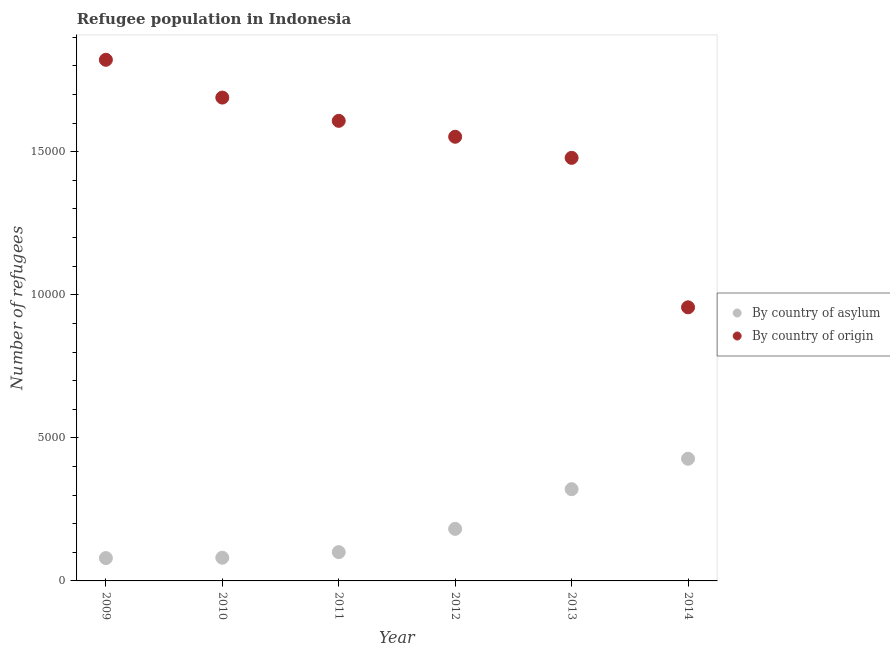How many different coloured dotlines are there?
Offer a terse response. 2. What is the number of refugees by country of origin in 2011?
Provide a short and direct response. 1.61e+04. Across all years, what is the maximum number of refugees by country of asylum?
Ensure brevity in your answer.  4270. Across all years, what is the minimum number of refugees by country of origin?
Make the answer very short. 9562. In which year was the number of refugees by country of origin maximum?
Offer a very short reply. 2009. What is the total number of refugees by country of asylum in the graph?
Provide a short and direct response. 1.19e+04. What is the difference between the number of refugees by country of asylum in 2009 and that in 2014?
Offer a terse response. -3472. What is the difference between the number of refugees by country of asylum in 2010 and the number of refugees by country of origin in 2009?
Ensure brevity in your answer.  -1.74e+04. What is the average number of refugees by country of origin per year?
Ensure brevity in your answer.  1.52e+04. In the year 2012, what is the difference between the number of refugees by country of asylum and number of refugees by country of origin?
Your response must be concise. -1.37e+04. What is the ratio of the number of refugees by country of origin in 2011 to that in 2013?
Provide a succinct answer. 1.09. What is the difference between the highest and the second highest number of refugees by country of asylum?
Offer a very short reply. 1064. What is the difference between the highest and the lowest number of refugees by country of asylum?
Your answer should be compact. 3472. Is the number of refugees by country of asylum strictly less than the number of refugees by country of origin over the years?
Keep it short and to the point. Yes. How many dotlines are there?
Provide a short and direct response. 2. What is the difference between two consecutive major ticks on the Y-axis?
Make the answer very short. 5000. Does the graph contain any zero values?
Provide a succinct answer. No. Does the graph contain grids?
Your answer should be very brief. No. Where does the legend appear in the graph?
Offer a very short reply. Center right. How are the legend labels stacked?
Provide a short and direct response. Vertical. What is the title of the graph?
Your answer should be compact. Refugee population in Indonesia. Does "% of gross capital formation" appear as one of the legend labels in the graph?
Your answer should be very brief. No. What is the label or title of the Y-axis?
Provide a short and direct response. Number of refugees. What is the Number of refugees of By country of asylum in 2009?
Your answer should be very brief. 798. What is the Number of refugees of By country of origin in 2009?
Ensure brevity in your answer.  1.82e+04. What is the Number of refugees in By country of asylum in 2010?
Your response must be concise. 811. What is the Number of refugees in By country of origin in 2010?
Keep it short and to the point. 1.69e+04. What is the Number of refugees in By country of asylum in 2011?
Your answer should be very brief. 1006. What is the Number of refugees of By country of origin in 2011?
Provide a succinct answer. 1.61e+04. What is the Number of refugees in By country of asylum in 2012?
Provide a short and direct response. 1819. What is the Number of refugees in By country of origin in 2012?
Your answer should be very brief. 1.55e+04. What is the Number of refugees in By country of asylum in 2013?
Your answer should be compact. 3206. What is the Number of refugees in By country of origin in 2013?
Provide a succinct answer. 1.48e+04. What is the Number of refugees in By country of asylum in 2014?
Your answer should be compact. 4270. What is the Number of refugees of By country of origin in 2014?
Provide a succinct answer. 9562. Across all years, what is the maximum Number of refugees of By country of asylum?
Offer a very short reply. 4270. Across all years, what is the maximum Number of refugees in By country of origin?
Offer a terse response. 1.82e+04. Across all years, what is the minimum Number of refugees of By country of asylum?
Make the answer very short. 798. Across all years, what is the minimum Number of refugees in By country of origin?
Your answer should be compact. 9562. What is the total Number of refugees of By country of asylum in the graph?
Provide a short and direct response. 1.19e+04. What is the total Number of refugees of By country of origin in the graph?
Provide a short and direct response. 9.11e+04. What is the difference between the Number of refugees of By country of asylum in 2009 and that in 2010?
Provide a short and direct response. -13. What is the difference between the Number of refugees in By country of origin in 2009 and that in 2010?
Your response must be concise. 1321. What is the difference between the Number of refugees of By country of asylum in 2009 and that in 2011?
Keep it short and to the point. -208. What is the difference between the Number of refugees in By country of origin in 2009 and that in 2011?
Offer a very short reply. 2134. What is the difference between the Number of refugees in By country of asylum in 2009 and that in 2012?
Keep it short and to the point. -1021. What is the difference between the Number of refugees of By country of origin in 2009 and that in 2012?
Give a very brief answer. 2690. What is the difference between the Number of refugees of By country of asylum in 2009 and that in 2013?
Provide a succinct answer. -2408. What is the difference between the Number of refugees of By country of origin in 2009 and that in 2013?
Your response must be concise. 3427. What is the difference between the Number of refugees of By country of asylum in 2009 and that in 2014?
Your answer should be compact. -3472. What is the difference between the Number of refugees of By country of origin in 2009 and that in 2014?
Make the answer very short. 8651. What is the difference between the Number of refugees of By country of asylum in 2010 and that in 2011?
Provide a succinct answer. -195. What is the difference between the Number of refugees in By country of origin in 2010 and that in 2011?
Provide a succinct answer. 813. What is the difference between the Number of refugees of By country of asylum in 2010 and that in 2012?
Provide a succinct answer. -1008. What is the difference between the Number of refugees of By country of origin in 2010 and that in 2012?
Provide a succinct answer. 1369. What is the difference between the Number of refugees in By country of asylum in 2010 and that in 2013?
Give a very brief answer. -2395. What is the difference between the Number of refugees in By country of origin in 2010 and that in 2013?
Your response must be concise. 2106. What is the difference between the Number of refugees of By country of asylum in 2010 and that in 2014?
Keep it short and to the point. -3459. What is the difference between the Number of refugees in By country of origin in 2010 and that in 2014?
Ensure brevity in your answer.  7330. What is the difference between the Number of refugees of By country of asylum in 2011 and that in 2012?
Your answer should be very brief. -813. What is the difference between the Number of refugees in By country of origin in 2011 and that in 2012?
Ensure brevity in your answer.  556. What is the difference between the Number of refugees of By country of asylum in 2011 and that in 2013?
Your answer should be very brief. -2200. What is the difference between the Number of refugees of By country of origin in 2011 and that in 2013?
Your answer should be very brief. 1293. What is the difference between the Number of refugees in By country of asylum in 2011 and that in 2014?
Make the answer very short. -3264. What is the difference between the Number of refugees in By country of origin in 2011 and that in 2014?
Offer a very short reply. 6517. What is the difference between the Number of refugees of By country of asylum in 2012 and that in 2013?
Provide a succinct answer. -1387. What is the difference between the Number of refugees of By country of origin in 2012 and that in 2013?
Provide a succinct answer. 737. What is the difference between the Number of refugees of By country of asylum in 2012 and that in 2014?
Give a very brief answer. -2451. What is the difference between the Number of refugees of By country of origin in 2012 and that in 2014?
Keep it short and to the point. 5961. What is the difference between the Number of refugees of By country of asylum in 2013 and that in 2014?
Offer a terse response. -1064. What is the difference between the Number of refugees in By country of origin in 2013 and that in 2014?
Keep it short and to the point. 5224. What is the difference between the Number of refugees in By country of asylum in 2009 and the Number of refugees in By country of origin in 2010?
Offer a terse response. -1.61e+04. What is the difference between the Number of refugees of By country of asylum in 2009 and the Number of refugees of By country of origin in 2011?
Your answer should be very brief. -1.53e+04. What is the difference between the Number of refugees of By country of asylum in 2009 and the Number of refugees of By country of origin in 2012?
Your answer should be very brief. -1.47e+04. What is the difference between the Number of refugees of By country of asylum in 2009 and the Number of refugees of By country of origin in 2013?
Give a very brief answer. -1.40e+04. What is the difference between the Number of refugees in By country of asylum in 2009 and the Number of refugees in By country of origin in 2014?
Provide a succinct answer. -8764. What is the difference between the Number of refugees in By country of asylum in 2010 and the Number of refugees in By country of origin in 2011?
Offer a very short reply. -1.53e+04. What is the difference between the Number of refugees in By country of asylum in 2010 and the Number of refugees in By country of origin in 2012?
Ensure brevity in your answer.  -1.47e+04. What is the difference between the Number of refugees in By country of asylum in 2010 and the Number of refugees in By country of origin in 2013?
Your answer should be compact. -1.40e+04. What is the difference between the Number of refugees of By country of asylum in 2010 and the Number of refugees of By country of origin in 2014?
Provide a succinct answer. -8751. What is the difference between the Number of refugees in By country of asylum in 2011 and the Number of refugees in By country of origin in 2012?
Offer a very short reply. -1.45e+04. What is the difference between the Number of refugees of By country of asylum in 2011 and the Number of refugees of By country of origin in 2013?
Offer a terse response. -1.38e+04. What is the difference between the Number of refugees of By country of asylum in 2011 and the Number of refugees of By country of origin in 2014?
Your answer should be compact. -8556. What is the difference between the Number of refugees of By country of asylum in 2012 and the Number of refugees of By country of origin in 2013?
Offer a terse response. -1.30e+04. What is the difference between the Number of refugees in By country of asylum in 2012 and the Number of refugees in By country of origin in 2014?
Your response must be concise. -7743. What is the difference between the Number of refugees of By country of asylum in 2013 and the Number of refugees of By country of origin in 2014?
Make the answer very short. -6356. What is the average Number of refugees in By country of asylum per year?
Give a very brief answer. 1985. What is the average Number of refugees in By country of origin per year?
Offer a terse response. 1.52e+04. In the year 2009, what is the difference between the Number of refugees in By country of asylum and Number of refugees in By country of origin?
Give a very brief answer. -1.74e+04. In the year 2010, what is the difference between the Number of refugees in By country of asylum and Number of refugees in By country of origin?
Keep it short and to the point. -1.61e+04. In the year 2011, what is the difference between the Number of refugees in By country of asylum and Number of refugees in By country of origin?
Your answer should be very brief. -1.51e+04. In the year 2012, what is the difference between the Number of refugees in By country of asylum and Number of refugees in By country of origin?
Give a very brief answer. -1.37e+04. In the year 2013, what is the difference between the Number of refugees of By country of asylum and Number of refugees of By country of origin?
Ensure brevity in your answer.  -1.16e+04. In the year 2014, what is the difference between the Number of refugees of By country of asylum and Number of refugees of By country of origin?
Ensure brevity in your answer.  -5292. What is the ratio of the Number of refugees of By country of asylum in 2009 to that in 2010?
Offer a very short reply. 0.98. What is the ratio of the Number of refugees of By country of origin in 2009 to that in 2010?
Offer a terse response. 1.08. What is the ratio of the Number of refugees in By country of asylum in 2009 to that in 2011?
Make the answer very short. 0.79. What is the ratio of the Number of refugees of By country of origin in 2009 to that in 2011?
Give a very brief answer. 1.13. What is the ratio of the Number of refugees of By country of asylum in 2009 to that in 2012?
Provide a succinct answer. 0.44. What is the ratio of the Number of refugees in By country of origin in 2009 to that in 2012?
Make the answer very short. 1.17. What is the ratio of the Number of refugees in By country of asylum in 2009 to that in 2013?
Your response must be concise. 0.25. What is the ratio of the Number of refugees in By country of origin in 2009 to that in 2013?
Your response must be concise. 1.23. What is the ratio of the Number of refugees of By country of asylum in 2009 to that in 2014?
Provide a short and direct response. 0.19. What is the ratio of the Number of refugees in By country of origin in 2009 to that in 2014?
Provide a short and direct response. 1.9. What is the ratio of the Number of refugees of By country of asylum in 2010 to that in 2011?
Your response must be concise. 0.81. What is the ratio of the Number of refugees in By country of origin in 2010 to that in 2011?
Make the answer very short. 1.05. What is the ratio of the Number of refugees of By country of asylum in 2010 to that in 2012?
Offer a terse response. 0.45. What is the ratio of the Number of refugees in By country of origin in 2010 to that in 2012?
Keep it short and to the point. 1.09. What is the ratio of the Number of refugees of By country of asylum in 2010 to that in 2013?
Provide a succinct answer. 0.25. What is the ratio of the Number of refugees in By country of origin in 2010 to that in 2013?
Your answer should be compact. 1.14. What is the ratio of the Number of refugees of By country of asylum in 2010 to that in 2014?
Keep it short and to the point. 0.19. What is the ratio of the Number of refugees of By country of origin in 2010 to that in 2014?
Your response must be concise. 1.77. What is the ratio of the Number of refugees in By country of asylum in 2011 to that in 2012?
Make the answer very short. 0.55. What is the ratio of the Number of refugees of By country of origin in 2011 to that in 2012?
Your response must be concise. 1.04. What is the ratio of the Number of refugees of By country of asylum in 2011 to that in 2013?
Keep it short and to the point. 0.31. What is the ratio of the Number of refugees of By country of origin in 2011 to that in 2013?
Give a very brief answer. 1.09. What is the ratio of the Number of refugees in By country of asylum in 2011 to that in 2014?
Give a very brief answer. 0.24. What is the ratio of the Number of refugees in By country of origin in 2011 to that in 2014?
Provide a short and direct response. 1.68. What is the ratio of the Number of refugees in By country of asylum in 2012 to that in 2013?
Make the answer very short. 0.57. What is the ratio of the Number of refugees of By country of origin in 2012 to that in 2013?
Keep it short and to the point. 1.05. What is the ratio of the Number of refugees of By country of asylum in 2012 to that in 2014?
Keep it short and to the point. 0.43. What is the ratio of the Number of refugees in By country of origin in 2012 to that in 2014?
Offer a terse response. 1.62. What is the ratio of the Number of refugees of By country of asylum in 2013 to that in 2014?
Ensure brevity in your answer.  0.75. What is the ratio of the Number of refugees in By country of origin in 2013 to that in 2014?
Provide a short and direct response. 1.55. What is the difference between the highest and the second highest Number of refugees in By country of asylum?
Offer a terse response. 1064. What is the difference between the highest and the second highest Number of refugees of By country of origin?
Your answer should be compact. 1321. What is the difference between the highest and the lowest Number of refugees in By country of asylum?
Ensure brevity in your answer.  3472. What is the difference between the highest and the lowest Number of refugees of By country of origin?
Offer a terse response. 8651. 